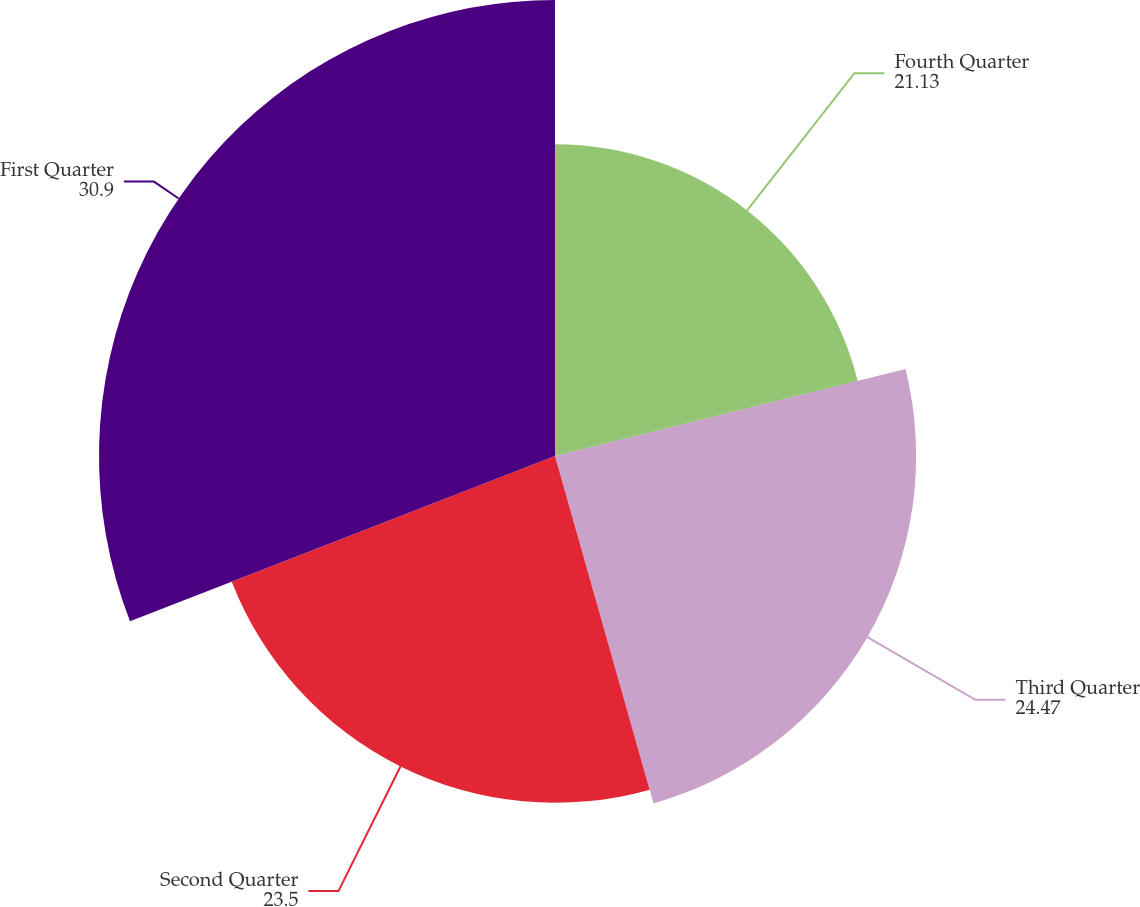<chart> <loc_0><loc_0><loc_500><loc_500><pie_chart><fcel>Fourth Quarter<fcel>Third Quarter<fcel>Second Quarter<fcel>First Quarter<nl><fcel>21.13%<fcel>24.47%<fcel>23.5%<fcel>30.9%<nl></chart> 